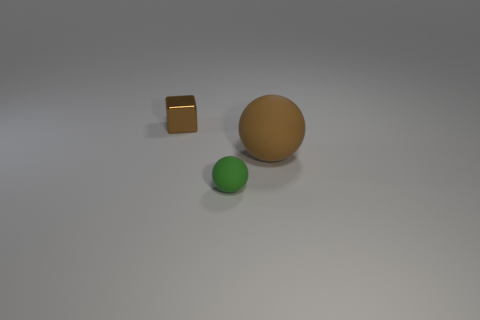How many yellow things are either small metallic things or balls?
Ensure brevity in your answer.  0. Does the brown metal thing have the same size as the ball that is to the left of the big brown thing?
Provide a succinct answer. Yes. There is a tiny object that is the same shape as the large object; what is it made of?
Your response must be concise. Rubber. How many other things are there of the same size as the brown rubber ball?
Keep it short and to the point. 0. There is a tiny object that is behind the rubber sphere behind the matte sphere that is in front of the large brown thing; what is its shape?
Ensure brevity in your answer.  Cube. The object that is both to the left of the large brown ball and behind the green thing has what shape?
Ensure brevity in your answer.  Cube. How many objects are either big brown spheres or balls behind the small green ball?
Your answer should be very brief. 1. Does the big brown thing have the same material as the small brown thing?
Offer a very short reply. No. How many other things are there of the same shape as the green thing?
Ensure brevity in your answer.  1. What size is the thing that is both in front of the tiny brown cube and behind the small green ball?
Offer a very short reply. Large. 